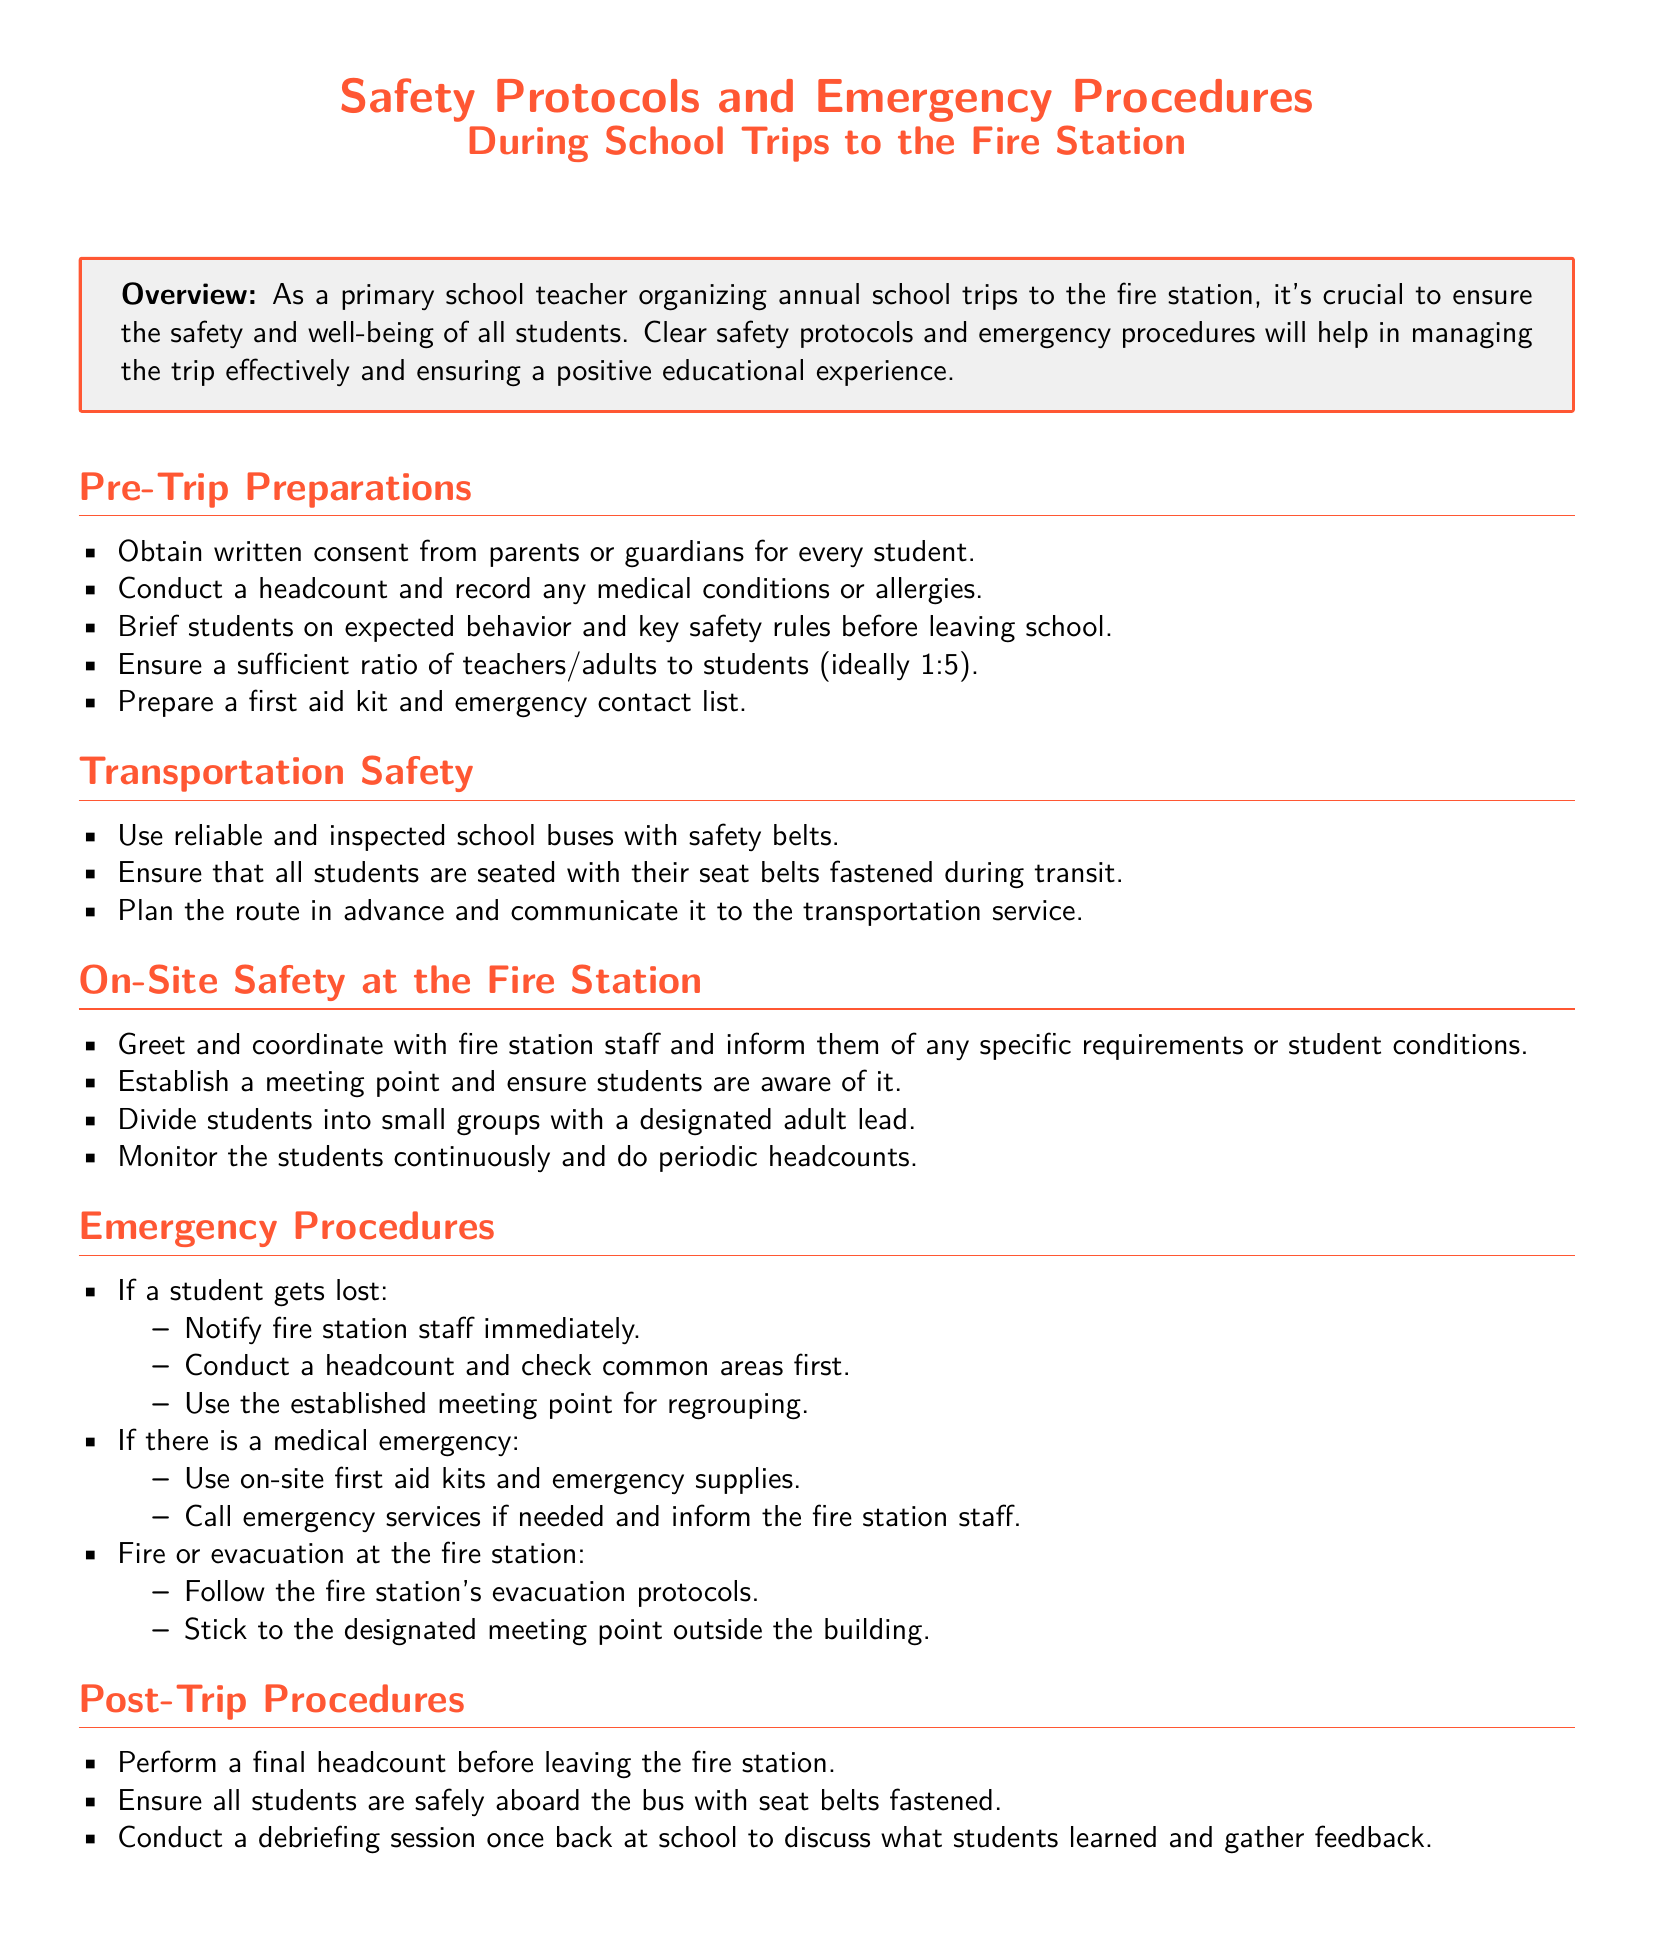What is the ideal teacher-to-student ratio? The document states that the ideal ratio is 1:5 in order to ensure safety and supervision during the trip.
Answer: 1:5 What should be prepared before the trip? The document lists preparing a first aid kit and an emergency contact list among other pre-trip preparations.
Answer: First aid kit and emergency contact list What should students be briefed on? The document mentions that students should be briefed on expected behavior and key safety rules prior to leaving the school.
Answer: Expected behavior and key safety rules What action should be taken if a student gets lost? The document advises to notify fire station staff and begin a headcount while checking common areas.
Answer: Notify fire station staff What is the first step in case of a medical emergency? According to the document, the first step is to use on-site first aid kits and emergency supplies.
Answer: Use on-site first aid kits What is established for students once on-site? The document mentions that a meeting point should be established and communicated to students.
Answer: Meeting point What should be performed before leaving the fire station? The document states that a final headcount should be performed before departure to ensure everyone is accounted for.
Answer: Final headcount What is conducted after returning to school? The document indicates that a debriefing session is conducted to discuss the trip and gather feedback from students.
Answer: Debriefing session 